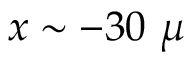<formula> <loc_0><loc_0><loc_500><loc_500>x \sim - 3 0 \ \mu</formula> 